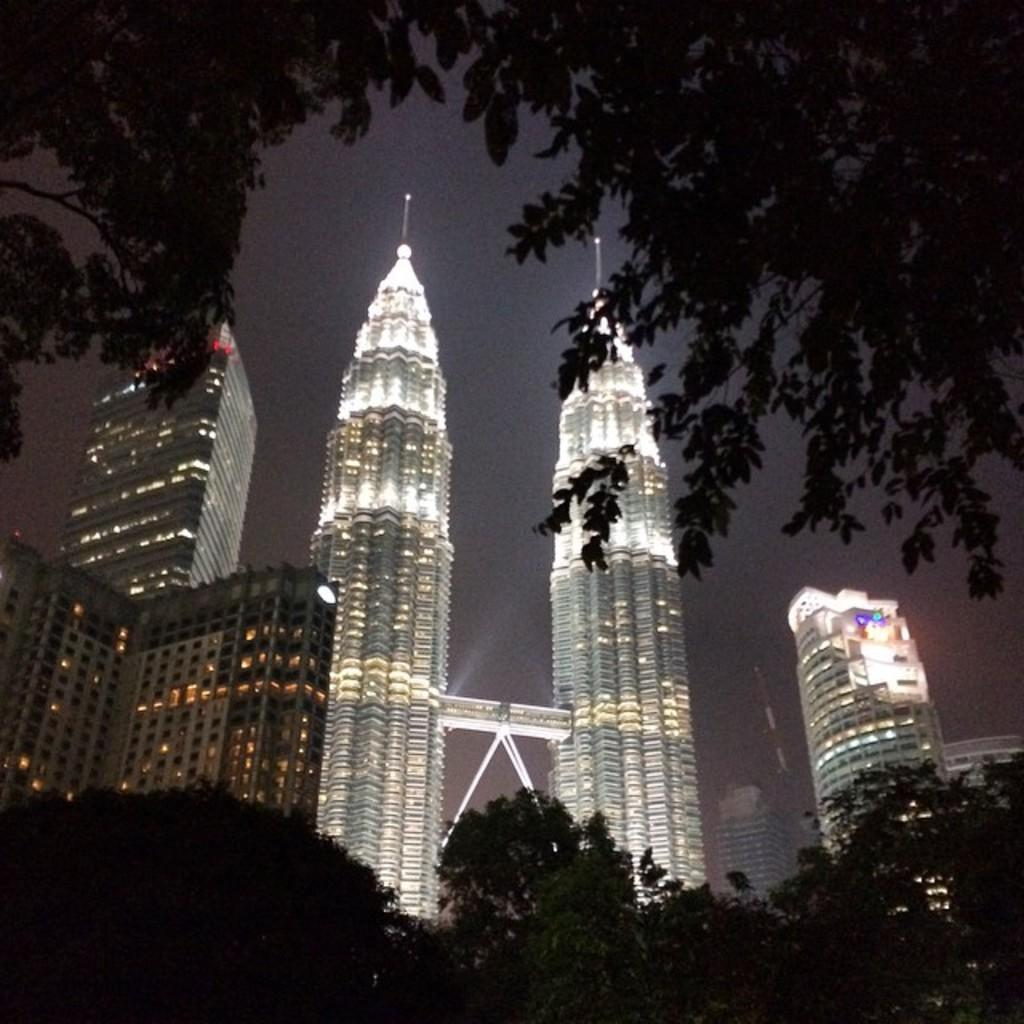What is located on the left side of the image? There is a tree on the left side of the image. What is located on the right side of the image? There is a tree on the right side of the image. What can be seen in the background of the image? There are trees and buildings in the background of the image. What is visible in the sky in the image? The sky is visible in the background of the image. How many lizards are sitting on the branches of the trees in the image? There are no lizards present in the image; it only features trees, buildings, and the sky. What type of feather can be seen floating in the sky in the image? There is no feather visible in the sky in the image. 